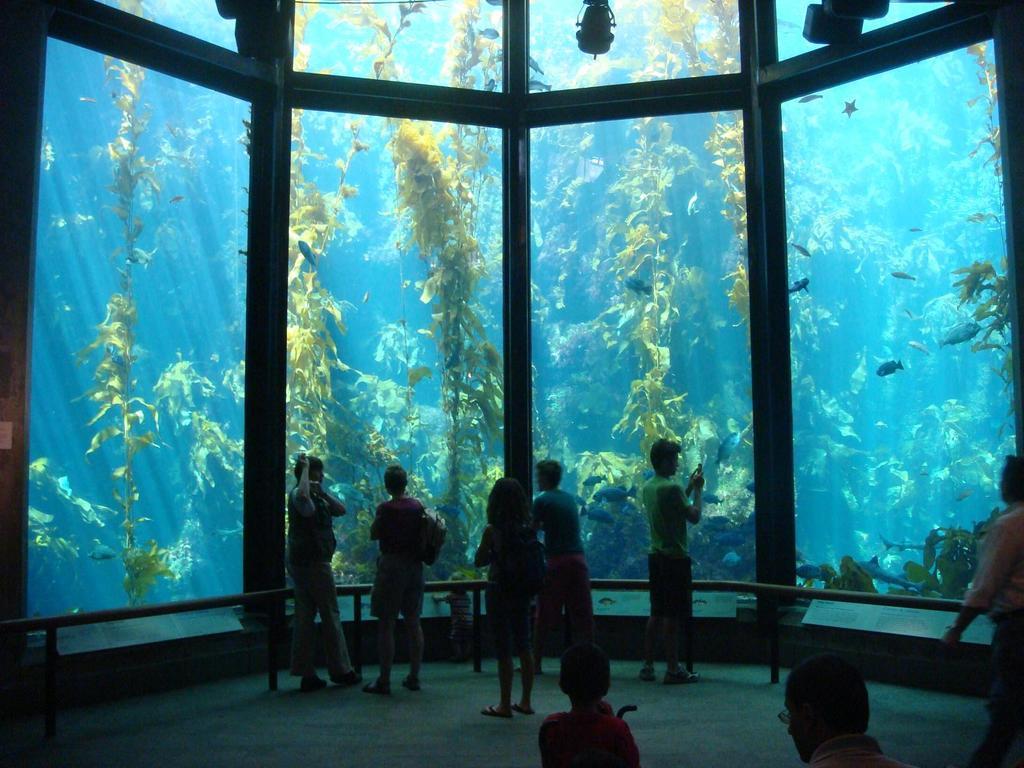Please provide a concise description of this image. In this image there are a few people standing, in front of them there is a fence and glass through which we can see there are plants fish in inside the glass. At the top of the image there are few objects. 